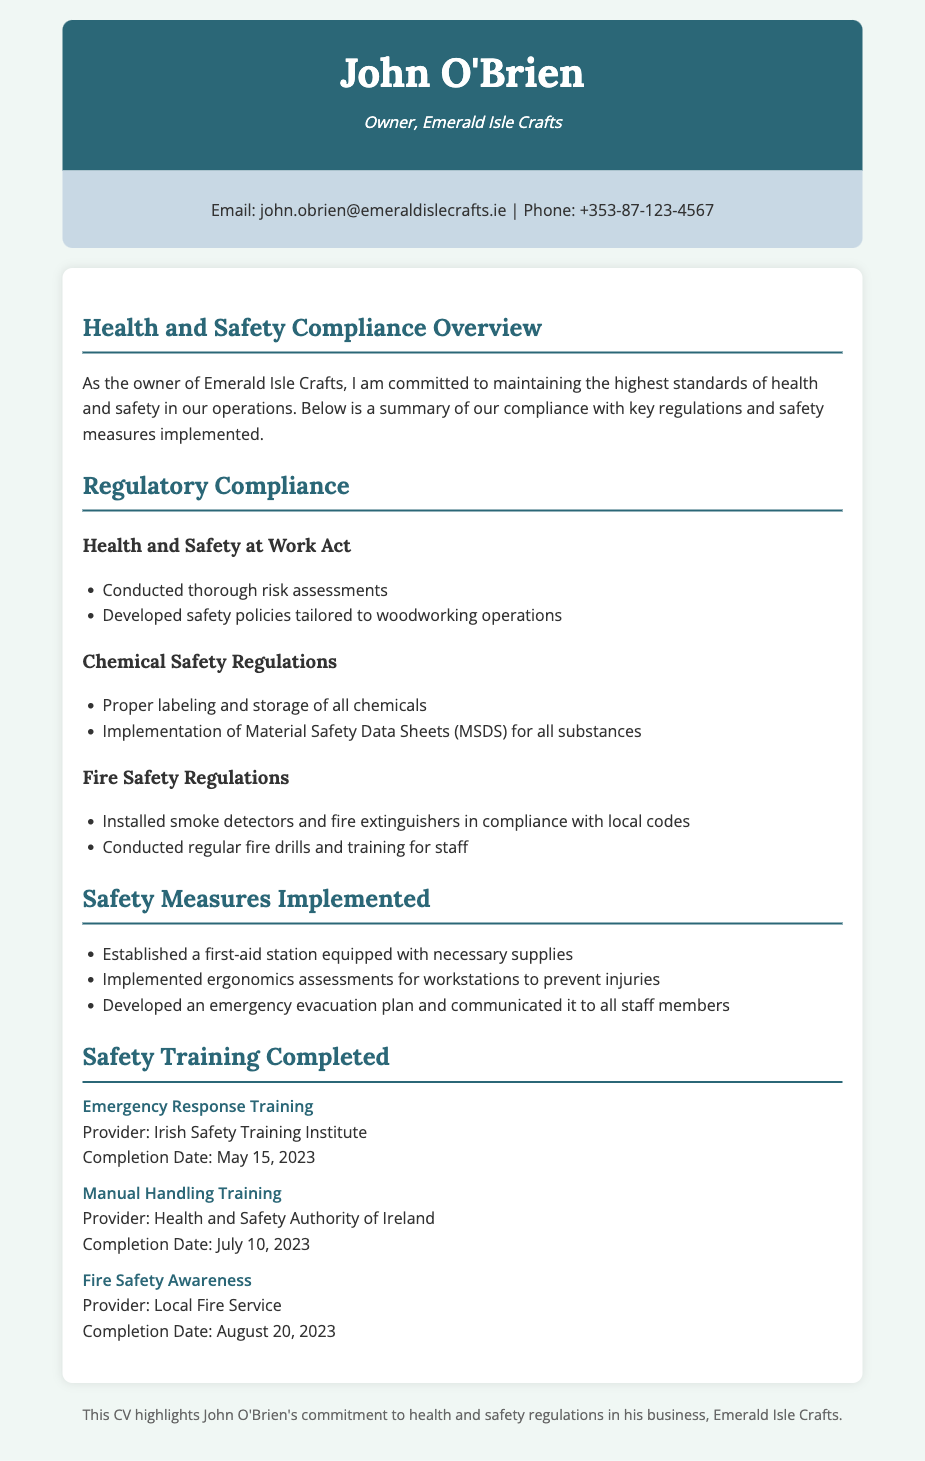what is the name of the business owner? The name of the business owner is prominently displayed at the top of the document.
Answer: John O'Brien what is the completion date for the Fire Safety Awareness training? This information can be found in the section detailing completed training, specifically under Fire Safety Awareness.
Answer: August 20, 2023 what type of training was completed on July 10, 2023? This date corresponds to a specific training session listed in the safety training section.
Answer: Manual Handling Training which act is mentioned in the regulatory compliance section? The title of the act is clearly mentioned under the Regulatory Compliance section.
Answer: Health and Safety at Work Act how many safety training courses are listed in the document? The total number of courses can be counted in the Safety Training Completed section.
Answer: Three what safety measure involves supplying first-aid items? This aspect is specified in the Safety Measures Implemented section of the document.
Answer: First-aid station which organization provided the Emergency Response Training? The provider's name is included in the description for Emergency Response Training in the CV.
Answer: Irish Safety Training Institute what is the purpose of the developed emergency evacuation plan? The plan's intent can be inferred from its description in the Safety Measures Implemented section.
Answer: To communicate to all staff members 